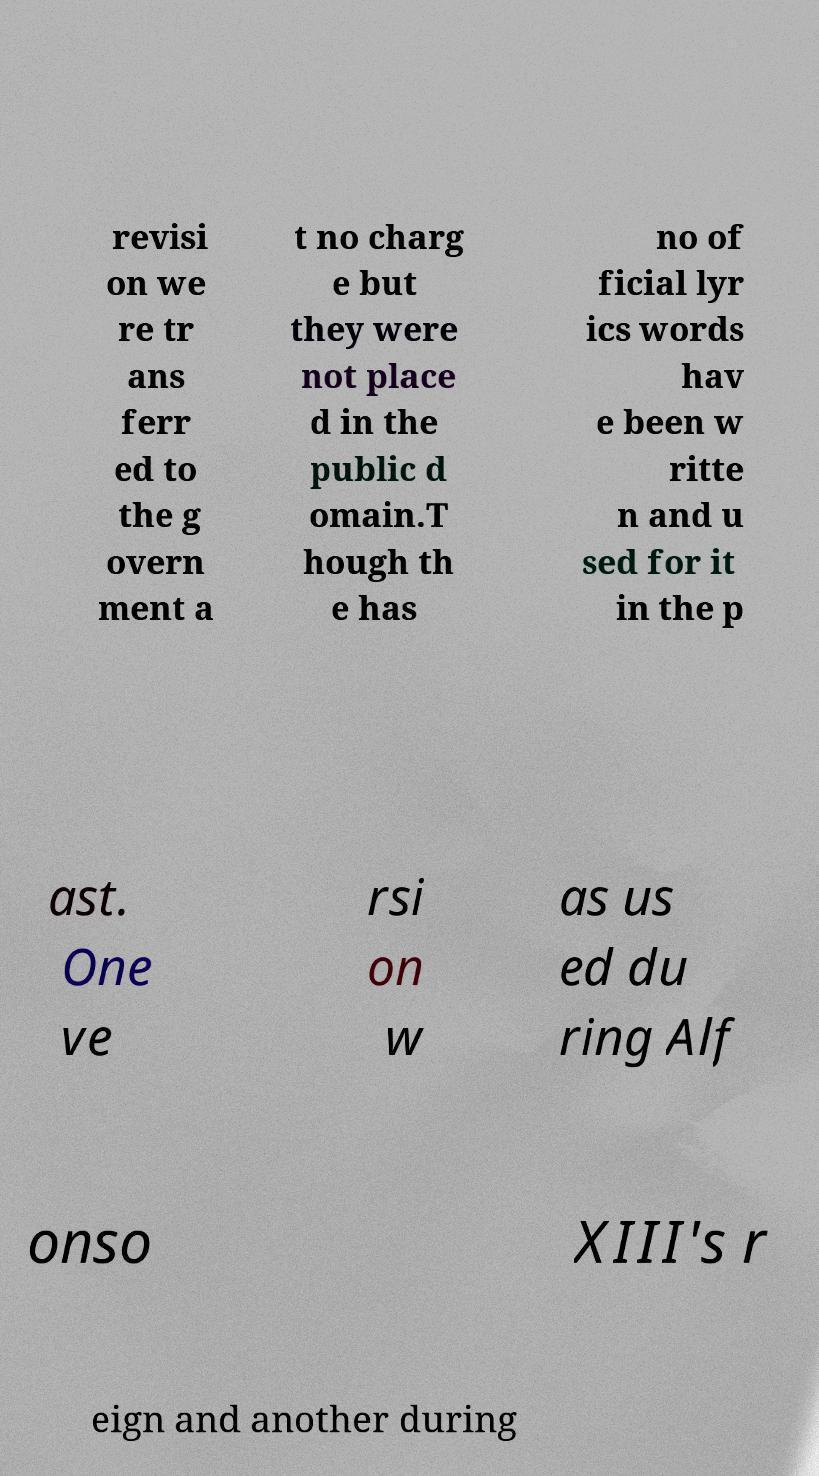Please read and relay the text visible in this image. What does it say? revisi on we re tr ans ferr ed to the g overn ment a t no charg e but they were not place d in the public d omain.T hough th e has no of ficial lyr ics words hav e been w ritte n and u sed for it in the p ast. One ve rsi on w as us ed du ring Alf onso XIII's r eign and another during 